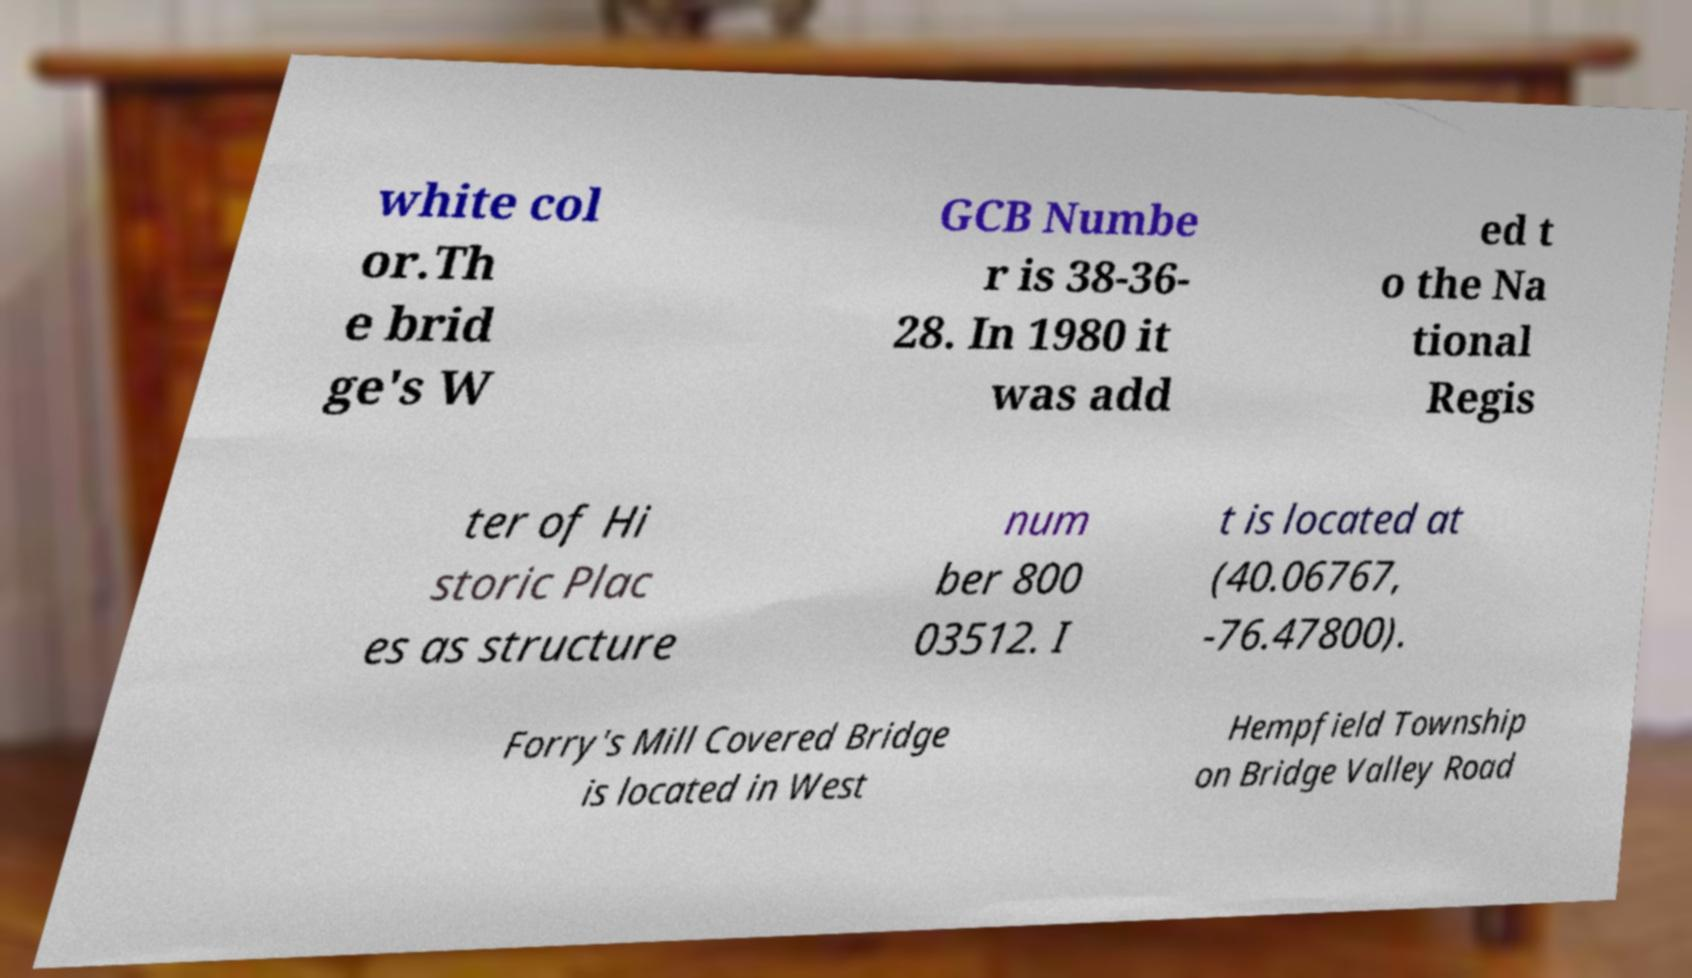For documentation purposes, I need the text within this image transcribed. Could you provide that? white col or.Th e brid ge's W GCB Numbe r is 38-36- 28. In 1980 it was add ed t o the Na tional Regis ter of Hi storic Plac es as structure num ber 800 03512. I t is located at (40.06767, -76.47800). Forry's Mill Covered Bridge is located in West Hempfield Township on Bridge Valley Road 